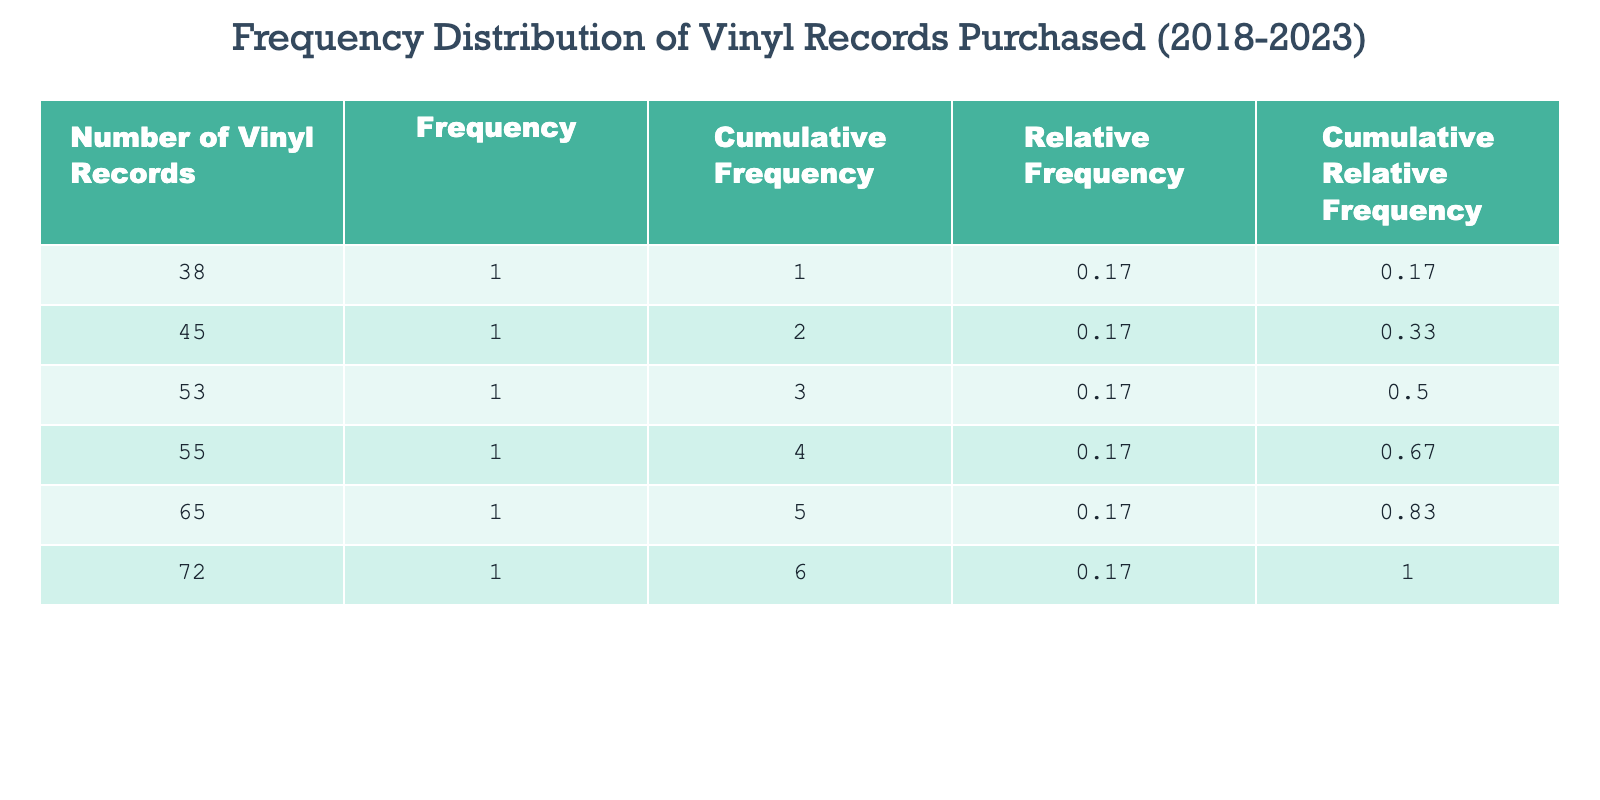What year had the highest number of vinyl records purchased? By looking at the "Number of Vinyl Records" column, I can see that 2022 has the highest value of 72. Therefore, the year with the highest number of records purchased is 2022.
Answer: 2022 What was the total number of vinyl records purchased from 2018 to 2023? To find the total, I sum the values in the "Number of Vinyl Records Purchased" column: 45 + 53 + 38 + 65 + 72 + 55 = 328. Thus, the total number is 328.
Answer: 328 In which year was the frequency of vinyl records purchased less than 50? Checking the "Number of Vinyl Records Purchased" for each year, I find that both 2018 (45) and 2020 (38) have values less than 50. So, the years are 2018 and 2020.
Answer: 2018, 2020 Was the number of vinyl records purchased in 2021 greater than the number purchased in 2023? Comparing the numbers, 2021 has 65 and 2023 has 55. Since 65 is greater than 55, the statement is true.
Answer: Yes What was the average number of vinyl records purchased per year from 2018 to 2023? The average is calculated by dividing the total sum of records (328) by the number of years (6): 328 / 6 = 54.67. Therefore, the average number of records is approximately 54.67.
Answer: 54.67 How many more records were purchased in 2022 compared to 2020? I find the values for 2022 (72) and 2020 (38). The difference is 72 - 38 = 34. Therefore, 34 more records were purchased in 2022 compared to 2020.
Answer: 34 Which year saw the least number of vinyl records purchased? Looking at the "Number of Vinyl Records" column, I can see that 2020 has the lowest value at 38. Hence, the year with the least number of records purchased is 2020.
Answer: 2020 Are there any years where the number of vinyl records purchased was exactly 55? Checking the values for each year, I find that the only year with an exact value of 55 is 2023. Thus, the answer is yes, and the year is 2023.
Answer: Yes What is the cumulative frequency of vinyl records purchased in 2021? From the cumulative frequency column, I see that the cumulative frequency for 2021 is 200 (which is the sum of all prior years' purchases plus 2021). Therefore, the cumulative frequency for 2021 is 200.
Answer: 200 